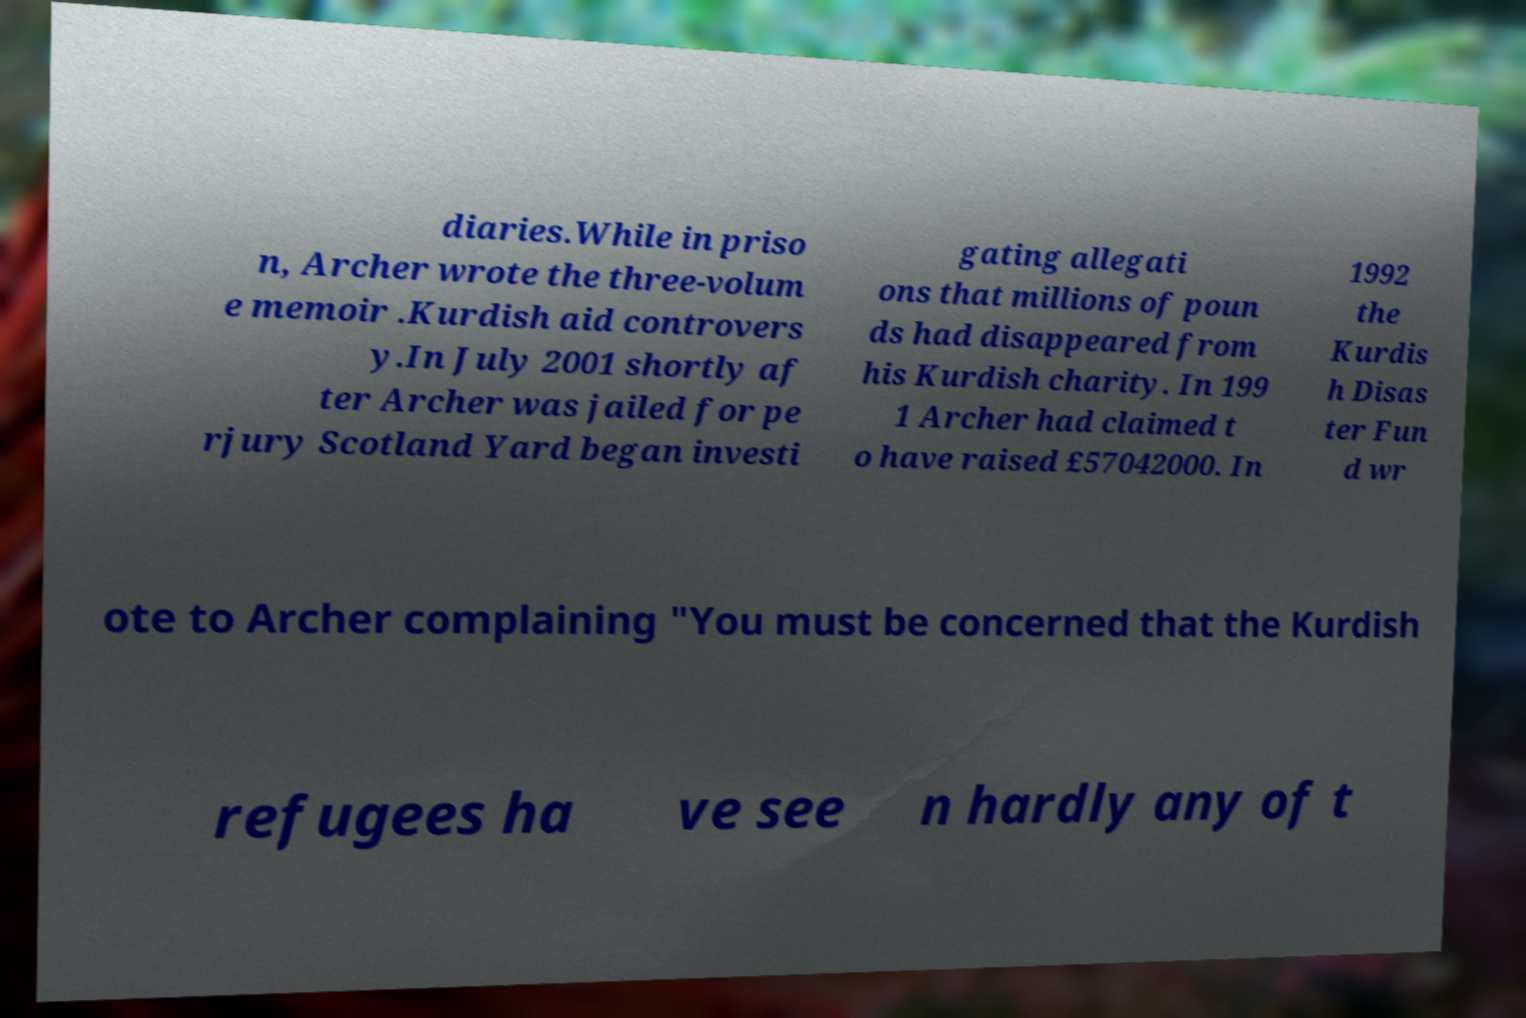Could you assist in decoding the text presented in this image and type it out clearly? diaries.While in priso n, Archer wrote the three-volum e memoir .Kurdish aid controvers y.In July 2001 shortly af ter Archer was jailed for pe rjury Scotland Yard began investi gating allegati ons that millions of poun ds had disappeared from his Kurdish charity. In 199 1 Archer had claimed t o have raised £57042000. In 1992 the Kurdis h Disas ter Fun d wr ote to Archer complaining "You must be concerned that the Kurdish refugees ha ve see n hardly any of t 